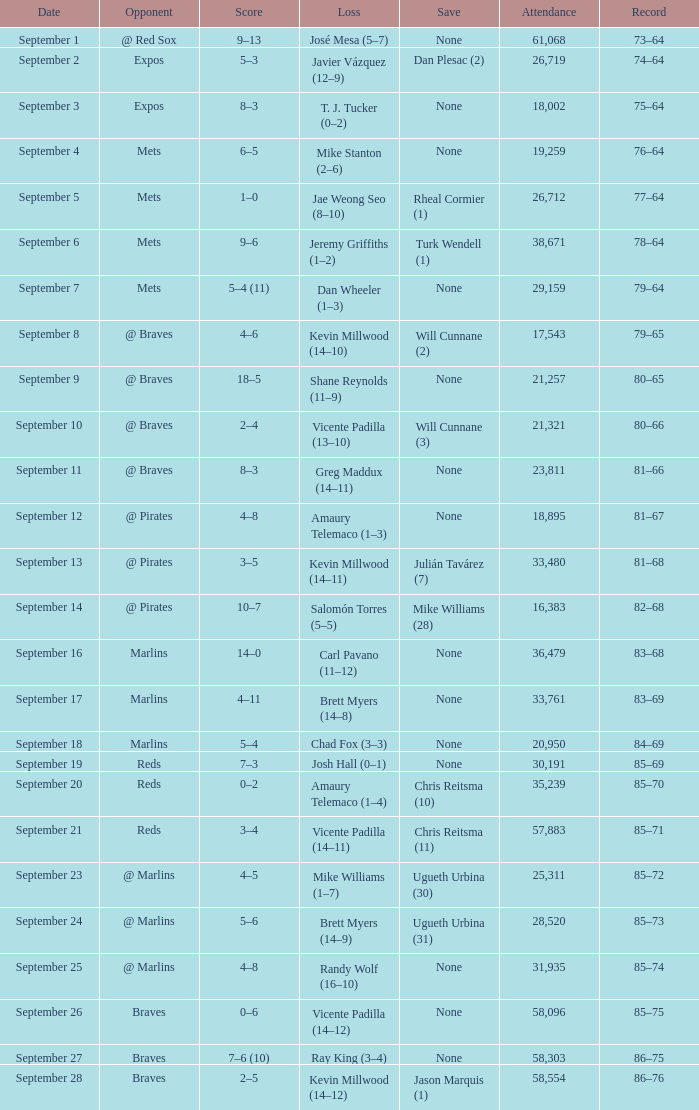What was the attendance at game with a loss of Josh Hall (0–1)? 30191.0. 